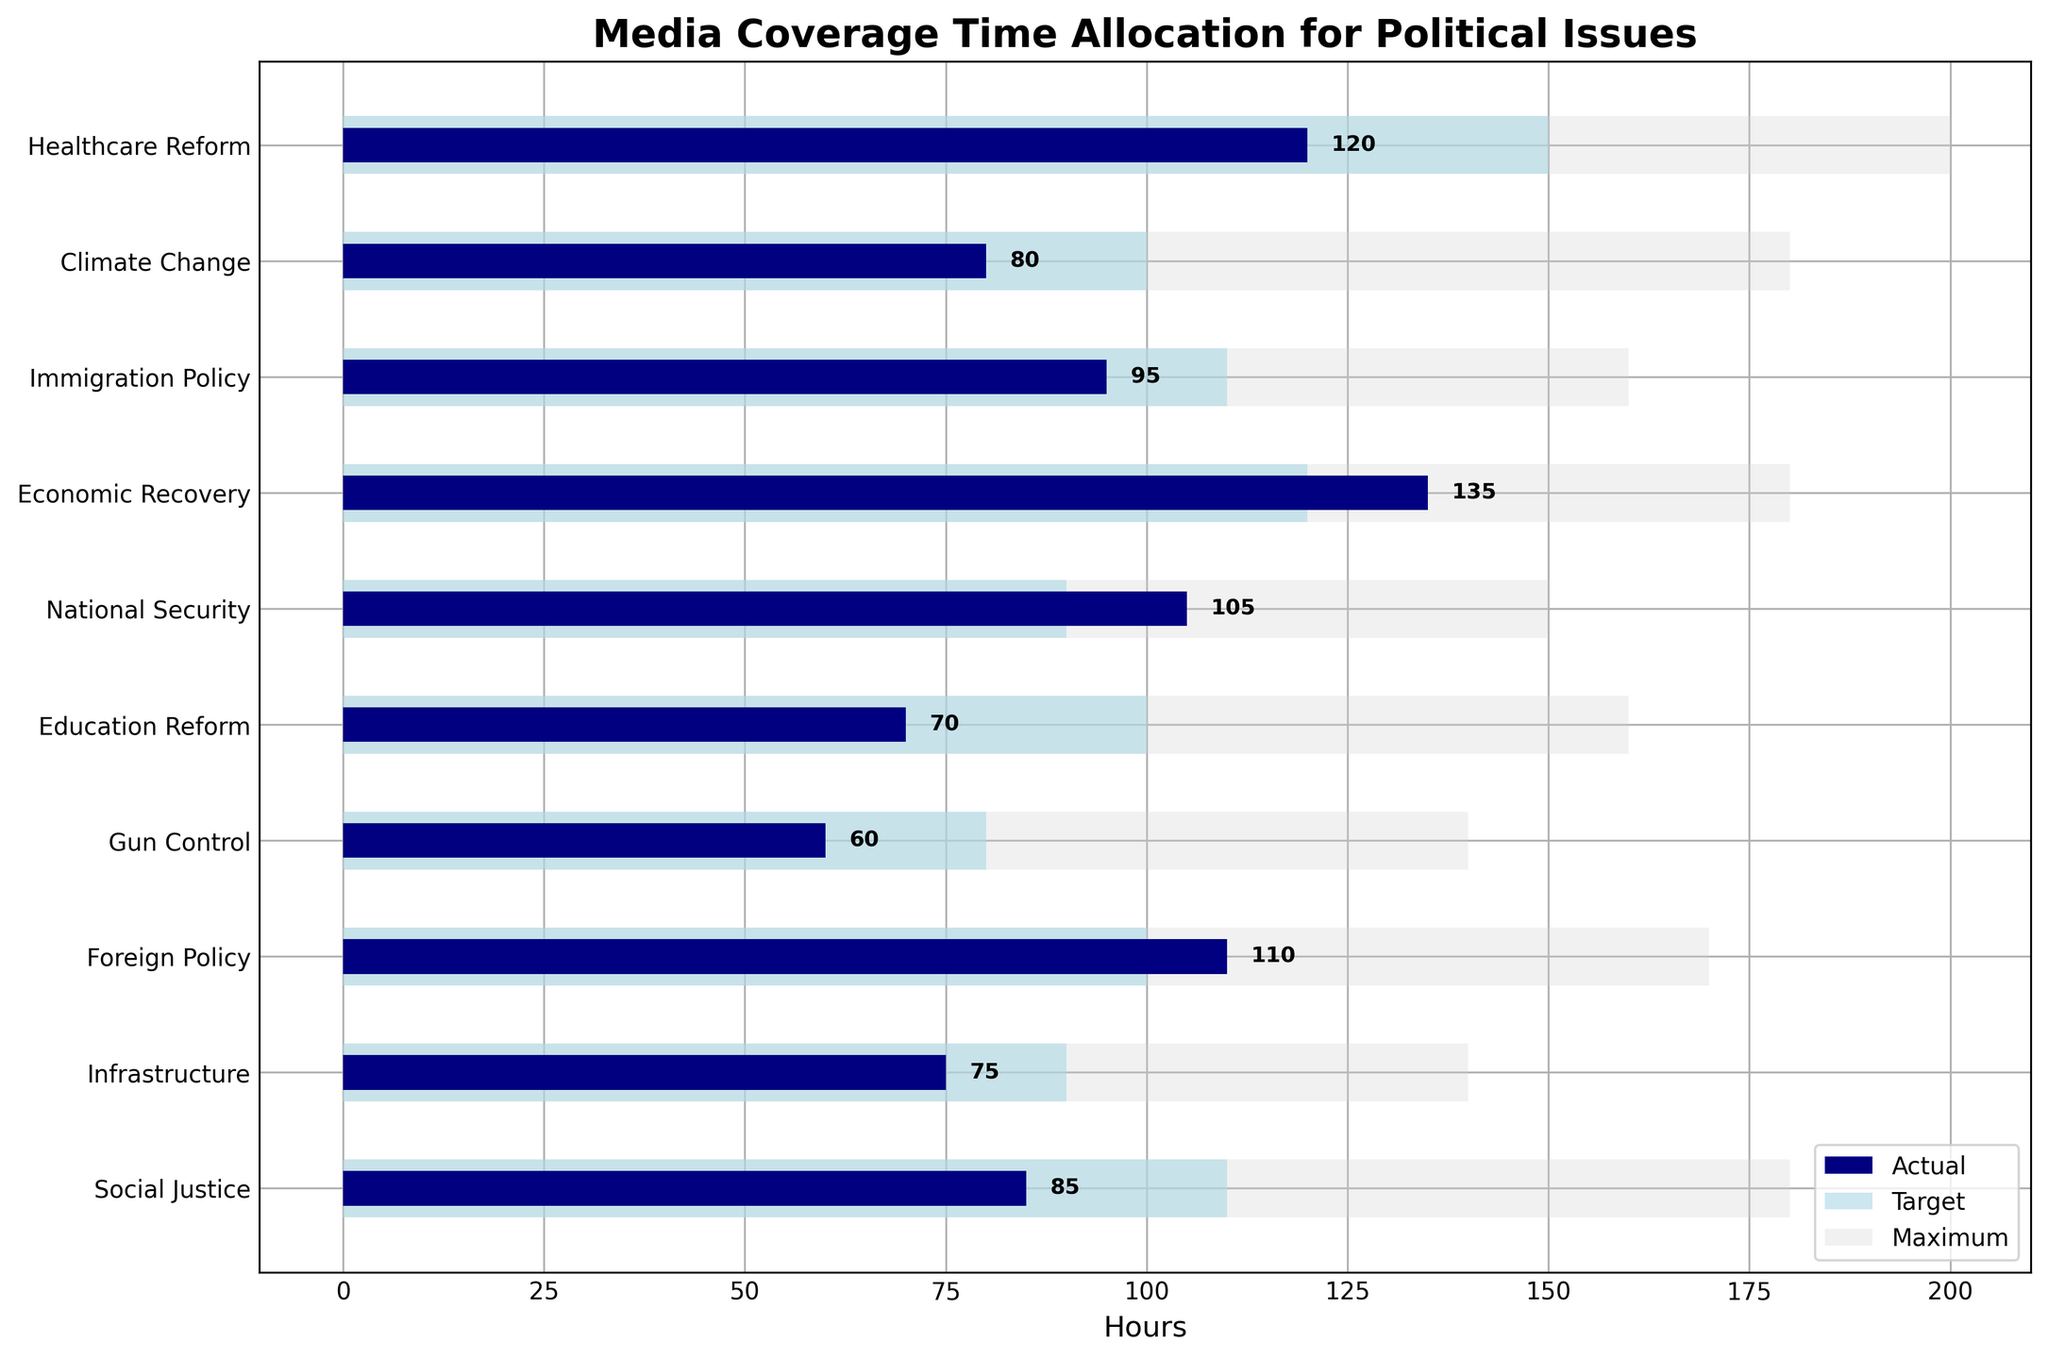What is the title of the figure? The title is displayed at the top of the chart. Reading it directly provides the answer.
Answer: Media Coverage Time Allocation for Political Issues How many political issues are covered in this figure? The number of horizontal bars represents the number of political issues. Counting them gives the answer.
Answer: 10 Which political issue has the least actual coverage hours? Find the shortest navy bar on the chart to determine which issue it represents.
Answer: Gun Control What are the actual coverage hours for Economic Recovery and National Security combined? Identify the actual coverage hours for both Economic Recovery and National Security, then add them together: 135 hours + 105 hours = 240 hours.
Answer: 240 Which issue has a larger discrepancy between actual and target coverage: Education Reform or Infrastructure? Compare the differences between the actual and target coverage for both issues: Education Reform (100 - 70 = 30), Infrastructure (90 - 75 = 15). Education Reform has a larger discrepancy.
Answer: Education Reform What is the difference between actual and maximum coverage hours for Healthcare Reform? Find the actual and maximum coverage hours for Healthcare Reform, then subtract the actual from the maximum: 200 hours - 120 hours = 80 hours.
Answer: 80 How does the actual coverage of Climate Change compare to its target coverage? Compare the length of the actual coverage bar (navy) with the target coverage bar (light blue) for Climate Change. The actual coverage (80 hours) is less than the target (100 hours).
Answer: Less than Which political issue meets or exceeds its target coverage hours? Identify the issues where the navy bar (actual coverage) is equal to or longer than the light blue bar (target coverage): Economic Recovery and National Security.
Answer: Economic Recovery, National Security By how many hours does the actual coverage for Foreign Policy exceed its target coverage? Compare the actual and target coverage of Foreign Policy: 110 hours (actual) - 100 hours (target) = 10 hours.
Answer: 10 